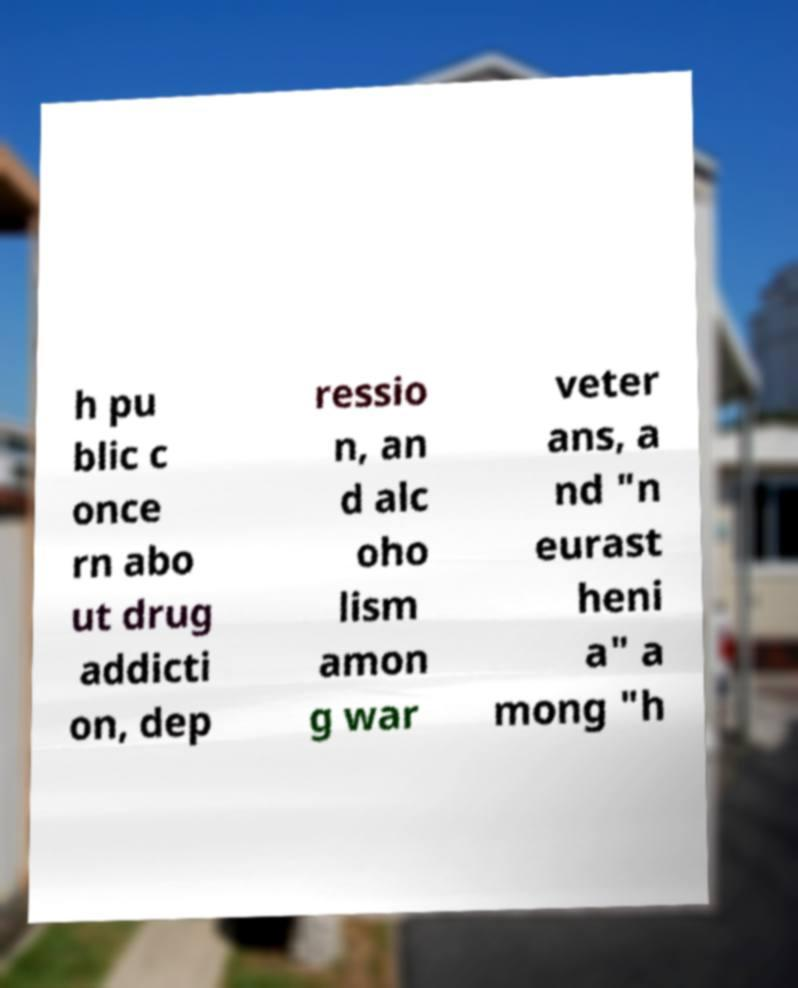Could you extract and type out the text from this image? h pu blic c once rn abo ut drug addicti on, dep ressio n, an d alc oho lism amon g war veter ans, a nd "n eurast heni a" a mong "h 